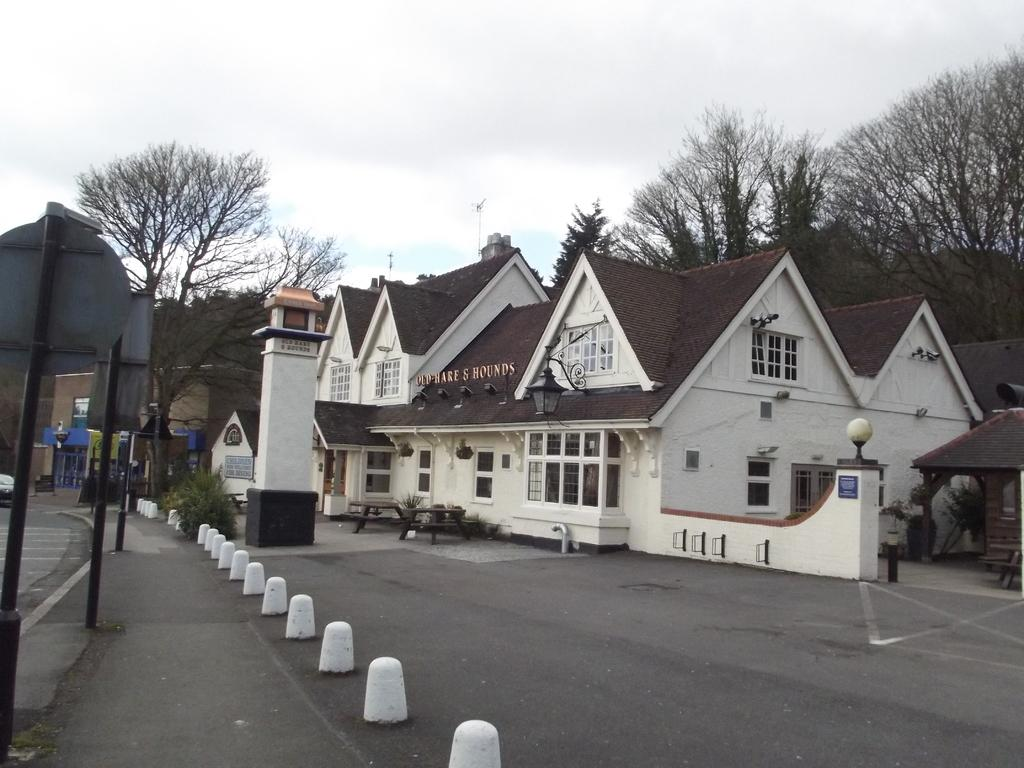What type of structures can be seen in the image? There are buildings with windows in the image. What is on the ground in the image? Tables are present on the ground. What objects are standing upright in the image? There are poles in the image. What type of vegetation is visible in the image? Trees are visible in the image. What can be seen in the background of the image? The sky with clouds is visible in the background. How many cherries are hanging from the poles in the image? There are no cherries present in the image; it features buildings, tables, poles, trees, and a sky with clouds. What type of cream is being used to paint the buildings in the image? There is no mention of cream or painting in the image; the buildings have windows and are not being painted. 